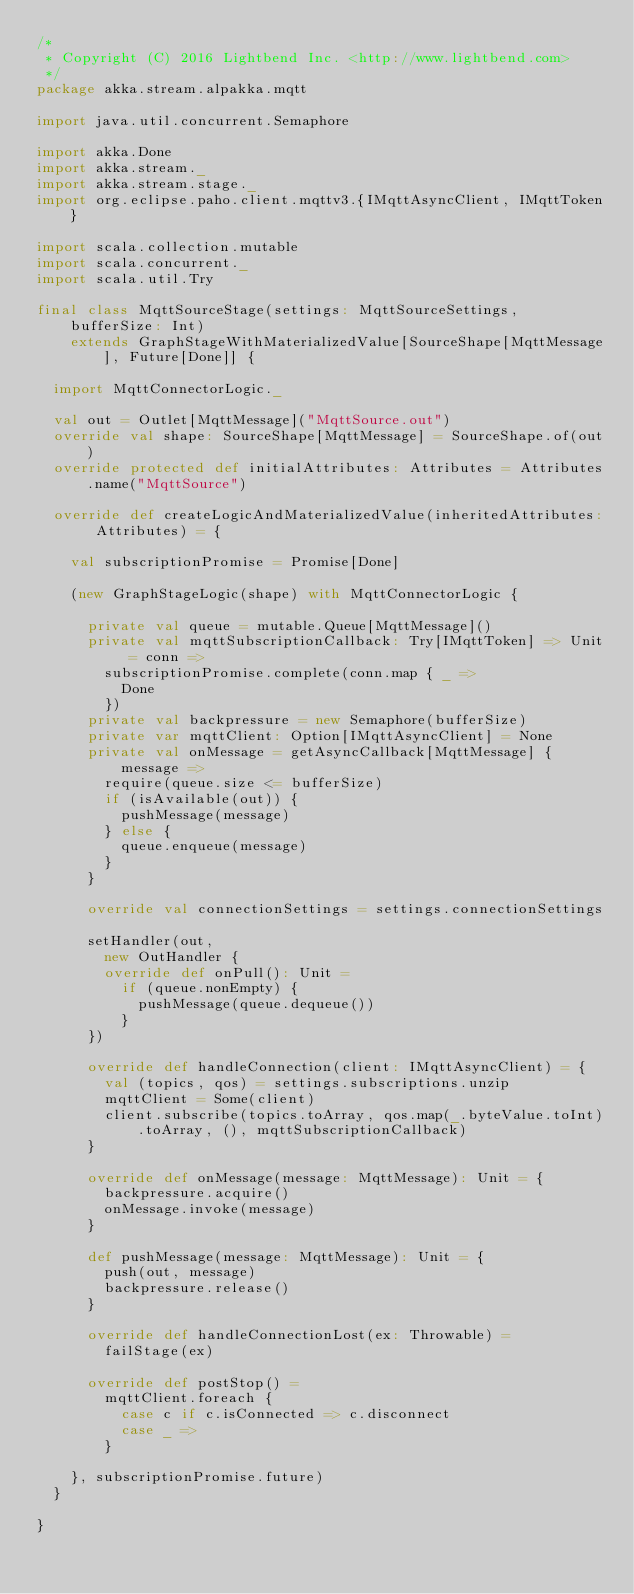<code> <loc_0><loc_0><loc_500><loc_500><_Scala_>/*
 * Copyright (C) 2016 Lightbend Inc. <http://www.lightbend.com>
 */
package akka.stream.alpakka.mqtt

import java.util.concurrent.Semaphore

import akka.Done
import akka.stream._
import akka.stream.stage._
import org.eclipse.paho.client.mqttv3.{IMqttAsyncClient, IMqttToken}

import scala.collection.mutable
import scala.concurrent._
import scala.util.Try

final class MqttSourceStage(settings: MqttSourceSettings, bufferSize: Int)
    extends GraphStageWithMaterializedValue[SourceShape[MqttMessage], Future[Done]] {

  import MqttConnectorLogic._

  val out = Outlet[MqttMessage]("MqttSource.out")
  override val shape: SourceShape[MqttMessage] = SourceShape.of(out)
  override protected def initialAttributes: Attributes = Attributes.name("MqttSource")

  override def createLogicAndMaterializedValue(inheritedAttributes: Attributes) = {

    val subscriptionPromise = Promise[Done]

    (new GraphStageLogic(shape) with MqttConnectorLogic {

      private val queue = mutable.Queue[MqttMessage]()
      private val mqttSubscriptionCallback: Try[IMqttToken] => Unit = conn =>
        subscriptionPromise.complete(conn.map { _ =>
          Done
        })
      private val backpressure = new Semaphore(bufferSize)
      private var mqttClient: Option[IMqttAsyncClient] = None
      private val onMessage = getAsyncCallback[MqttMessage] { message =>
        require(queue.size <= bufferSize)
        if (isAvailable(out)) {
          pushMessage(message)
        } else {
          queue.enqueue(message)
        }
      }

      override val connectionSettings = settings.connectionSettings

      setHandler(out,
        new OutHandler {
        override def onPull(): Unit =
          if (queue.nonEmpty) {
            pushMessage(queue.dequeue())
          }
      })

      override def handleConnection(client: IMqttAsyncClient) = {
        val (topics, qos) = settings.subscriptions.unzip
        mqttClient = Some(client)
        client.subscribe(topics.toArray, qos.map(_.byteValue.toInt).toArray, (), mqttSubscriptionCallback)
      }

      override def onMessage(message: MqttMessage): Unit = {
        backpressure.acquire()
        onMessage.invoke(message)
      }

      def pushMessage(message: MqttMessage): Unit = {
        push(out, message)
        backpressure.release()
      }

      override def handleConnectionLost(ex: Throwable) =
        failStage(ex)

      override def postStop() =
        mqttClient.foreach {
          case c if c.isConnected => c.disconnect
          case _ =>
        }

    }, subscriptionPromise.future)
  }

}
</code> 